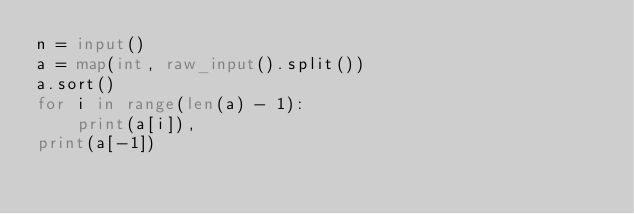Convert code to text. <code><loc_0><loc_0><loc_500><loc_500><_Python_>n = input()
a = map(int, raw_input().split())
a.sort()
for i in range(len(a) - 1):
    print(a[i]),
print(a[-1])</code> 